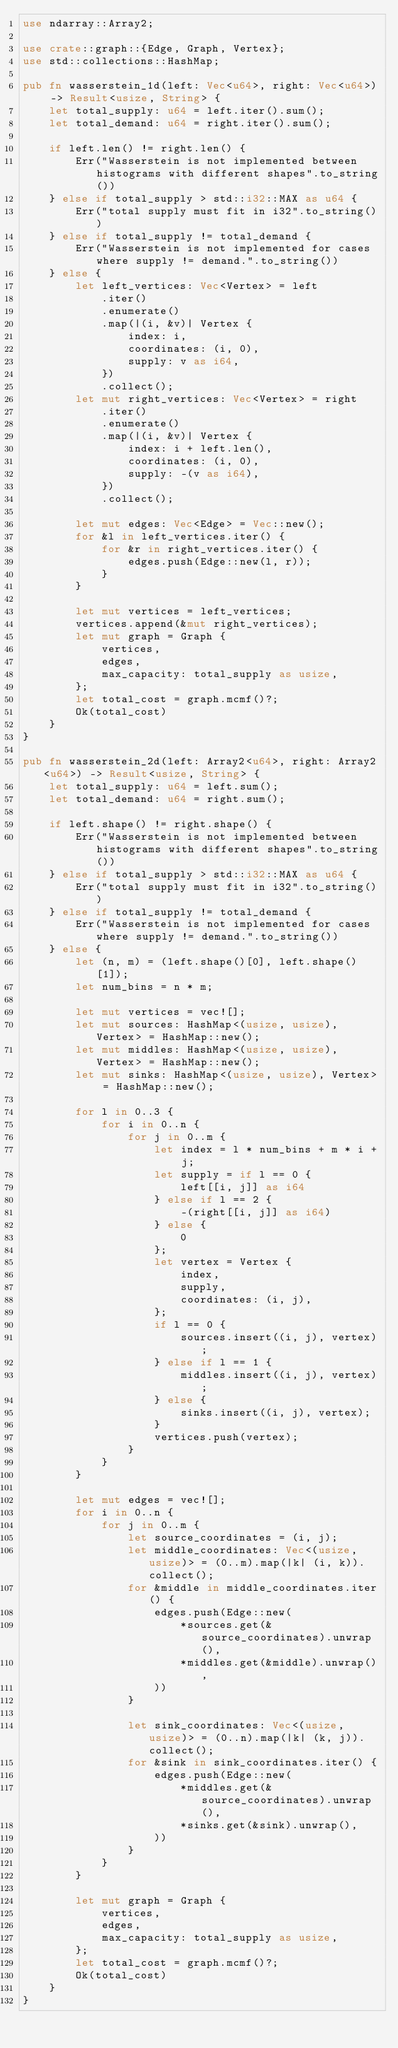<code> <loc_0><loc_0><loc_500><loc_500><_Rust_>use ndarray::Array2;

use crate::graph::{Edge, Graph, Vertex};
use std::collections::HashMap;

pub fn wasserstein_1d(left: Vec<u64>, right: Vec<u64>) -> Result<usize, String> {
    let total_supply: u64 = left.iter().sum();
    let total_demand: u64 = right.iter().sum();

    if left.len() != right.len() {
        Err("Wasserstein is not implemented between histograms with different shapes".to_string())
    } else if total_supply > std::i32::MAX as u64 {
        Err("total supply must fit in i32".to_string())
    } else if total_supply != total_demand {
        Err("Wasserstein is not implemented for cases where supply != demand.".to_string())
    } else {
        let left_vertices: Vec<Vertex> = left
            .iter()
            .enumerate()
            .map(|(i, &v)| Vertex {
                index: i,
                coordinates: (i, 0),
                supply: v as i64,
            })
            .collect();
        let mut right_vertices: Vec<Vertex> = right
            .iter()
            .enumerate()
            .map(|(i, &v)| Vertex {
                index: i + left.len(),
                coordinates: (i, 0),
                supply: -(v as i64),
            })
            .collect();

        let mut edges: Vec<Edge> = Vec::new();
        for &l in left_vertices.iter() {
            for &r in right_vertices.iter() {
                edges.push(Edge::new(l, r));
            }
        }

        let mut vertices = left_vertices;
        vertices.append(&mut right_vertices);
        let mut graph = Graph {
            vertices,
            edges,
            max_capacity: total_supply as usize,
        };
        let total_cost = graph.mcmf()?;
        Ok(total_cost)
    }
}

pub fn wasserstein_2d(left: Array2<u64>, right: Array2<u64>) -> Result<usize, String> {
    let total_supply: u64 = left.sum();
    let total_demand: u64 = right.sum();

    if left.shape() != right.shape() {
        Err("Wasserstein is not implemented between histograms with different shapes".to_string())
    } else if total_supply > std::i32::MAX as u64 {
        Err("total supply must fit in i32".to_string())
    } else if total_supply != total_demand {
        Err("Wasserstein is not implemented for cases where supply != demand.".to_string())
    } else {
        let (n, m) = (left.shape()[0], left.shape()[1]);
        let num_bins = n * m;

        let mut vertices = vec![];
        let mut sources: HashMap<(usize, usize), Vertex> = HashMap::new();
        let mut middles: HashMap<(usize, usize), Vertex> = HashMap::new();
        let mut sinks: HashMap<(usize, usize), Vertex> = HashMap::new();

        for l in 0..3 {
            for i in 0..n {
                for j in 0..m {
                    let index = l * num_bins + m * i + j;
                    let supply = if l == 0 {
                        left[[i, j]] as i64
                    } else if l == 2 {
                        -(right[[i, j]] as i64)
                    } else {
                        0
                    };
                    let vertex = Vertex {
                        index,
                        supply,
                        coordinates: (i, j),
                    };
                    if l == 0 {
                        sources.insert((i, j), vertex);
                    } else if l == 1 {
                        middles.insert((i, j), vertex);
                    } else {
                        sinks.insert((i, j), vertex);
                    }
                    vertices.push(vertex);
                }
            }
        }

        let mut edges = vec![];
        for i in 0..n {
            for j in 0..m {
                let source_coordinates = (i, j);
                let middle_coordinates: Vec<(usize, usize)> = (0..m).map(|k| (i, k)).collect();
                for &middle in middle_coordinates.iter() {
                    edges.push(Edge::new(
                        *sources.get(&source_coordinates).unwrap(),
                        *middles.get(&middle).unwrap(),
                    ))
                }

                let sink_coordinates: Vec<(usize, usize)> = (0..n).map(|k| (k, j)).collect();
                for &sink in sink_coordinates.iter() {
                    edges.push(Edge::new(
                        *middles.get(&source_coordinates).unwrap(),
                        *sinks.get(&sink).unwrap(),
                    ))
                }
            }
        }

        let mut graph = Graph {
            vertices,
            edges,
            max_capacity: total_supply as usize,
        };
        let total_cost = graph.mcmf()?;
        Ok(total_cost)
    }
}
</code> 